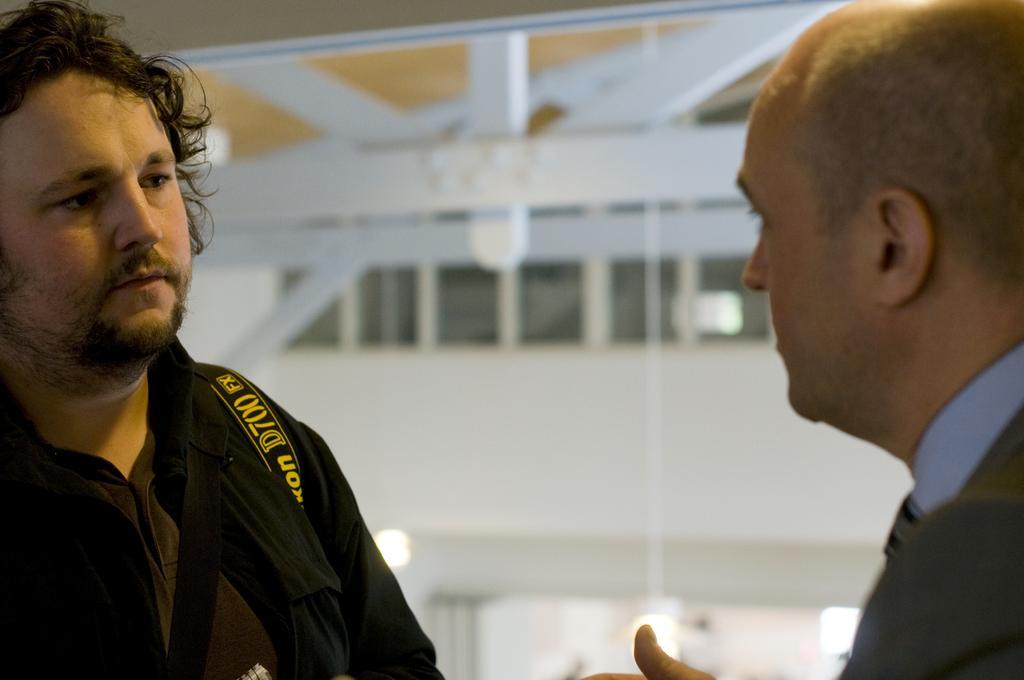In one or two sentences, can you explain what this image depicts? In the picture we can see a two men standing in the opposite direction and one man is talking to another man and in the background, we can see a wall with some windows and glasses to it and we can also see some lights. 